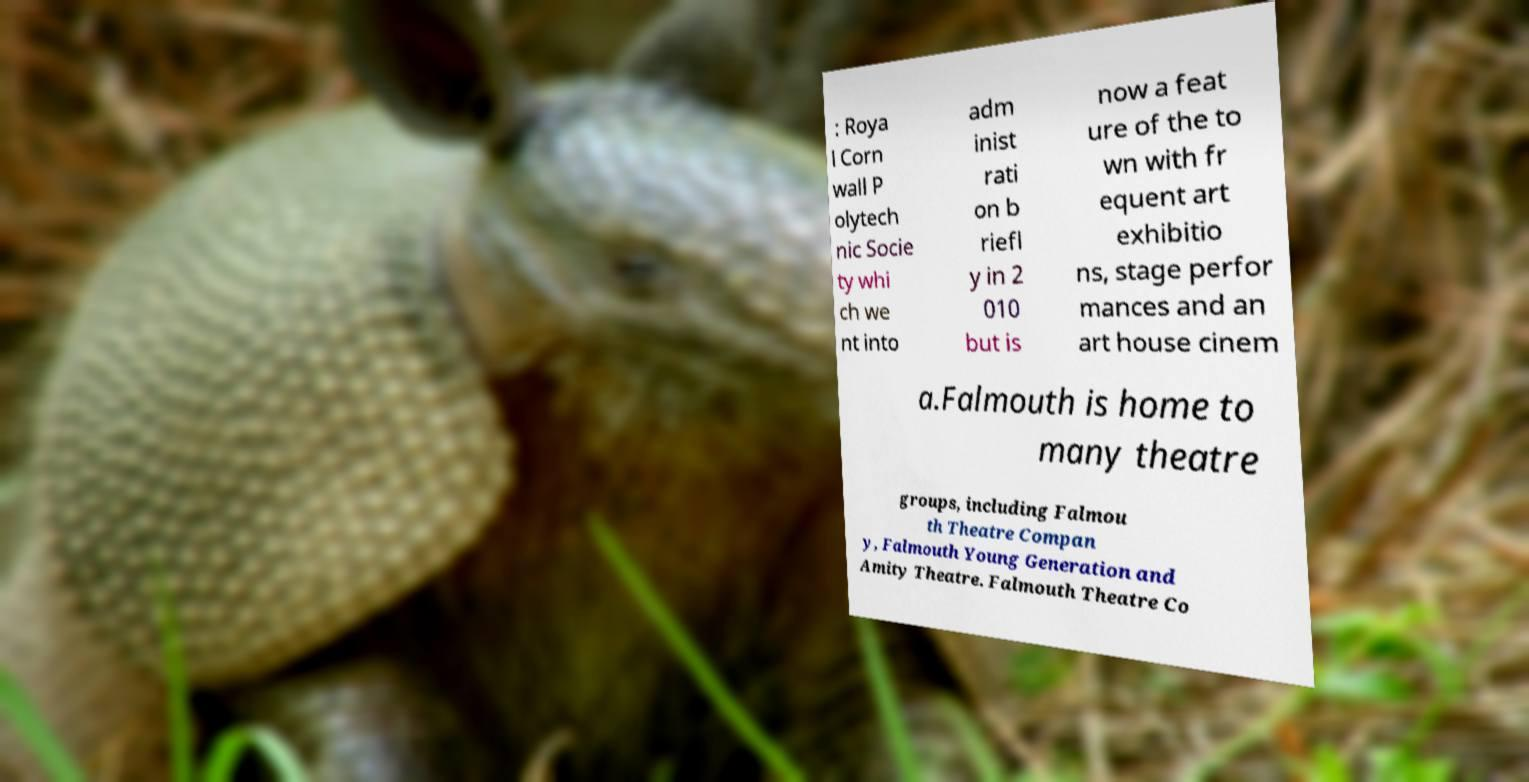There's text embedded in this image that I need extracted. Can you transcribe it verbatim? : Roya l Corn wall P olytech nic Socie ty whi ch we nt into adm inist rati on b riefl y in 2 010 but is now a feat ure of the to wn with fr equent art exhibitio ns, stage perfor mances and an art house cinem a.Falmouth is home to many theatre groups, including Falmou th Theatre Compan y, Falmouth Young Generation and Amity Theatre. Falmouth Theatre Co 